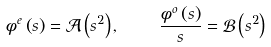<formula> <loc_0><loc_0><loc_500><loc_500>\phi ^ { e } \left ( s \right ) = \mathcal { A } \left ( s ^ { 2 } \right ) , \quad \frac { \phi ^ { o } \left ( s \right ) } { s } = \mathcal { B } \left ( s ^ { 2 } \right )</formula> 